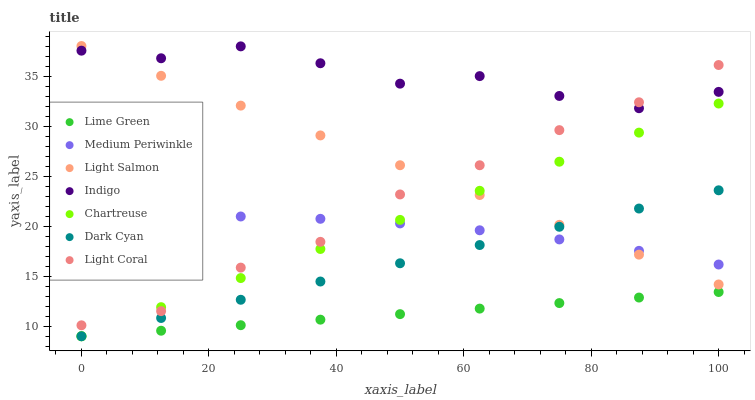Does Lime Green have the minimum area under the curve?
Answer yes or no. Yes. Does Indigo have the maximum area under the curve?
Answer yes or no. Yes. Does Medium Periwinkle have the minimum area under the curve?
Answer yes or no. No. Does Medium Periwinkle have the maximum area under the curve?
Answer yes or no. No. Is Chartreuse the smoothest?
Answer yes or no. Yes. Is Indigo the roughest?
Answer yes or no. Yes. Is Medium Periwinkle the smoothest?
Answer yes or no. No. Is Medium Periwinkle the roughest?
Answer yes or no. No. Does Chartreuse have the lowest value?
Answer yes or no. Yes. Does Medium Periwinkle have the lowest value?
Answer yes or no. No. Does Light Salmon have the highest value?
Answer yes or no. Yes. Does Indigo have the highest value?
Answer yes or no. No. Is Dark Cyan less than Indigo?
Answer yes or no. Yes. Is Indigo greater than Medium Periwinkle?
Answer yes or no. Yes. Does Light Coral intersect Medium Periwinkle?
Answer yes or no. Yes. Is Light Coral less than Medium Periwinkle?
Answer yes or no. No. Is Light Coral greater than Medium Periwinkle?
Answer yes or no. No. Does Dark Cyan intersect Indigo?
Answer yes or no. No. 